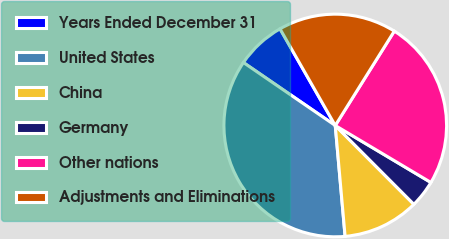Convert chart to OTSL. <chart><loc_0><loc_0><loc_500><loc_500><pie_chart><fcel>Years Ended December 31<fcel>United States<fcel>China<fcel>Germany<fcel>Other nations<fcel>Adjustments and Eliminations<nl><fcel>7.17%<fcel>35.97%<fcel>11.07%<fcel>3.97%<fcel>24.65%<fcel>17.16%<nl></chart> 